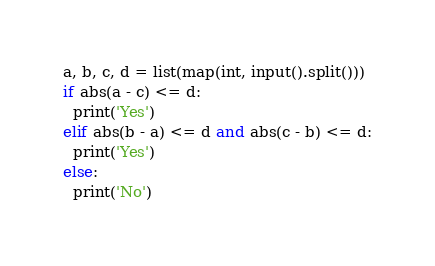Convert code to text. <code><loc_0><loc_0><loc_500><loc_500><_Python_>a, b, c, d = list(map(int, input().split()))
if abs(a - c) <= d:
  print('Yes')
elif abs(b - a) <= d and abs(c - b) <= d:
  print('Yes')
else:
  print('No')</code> 